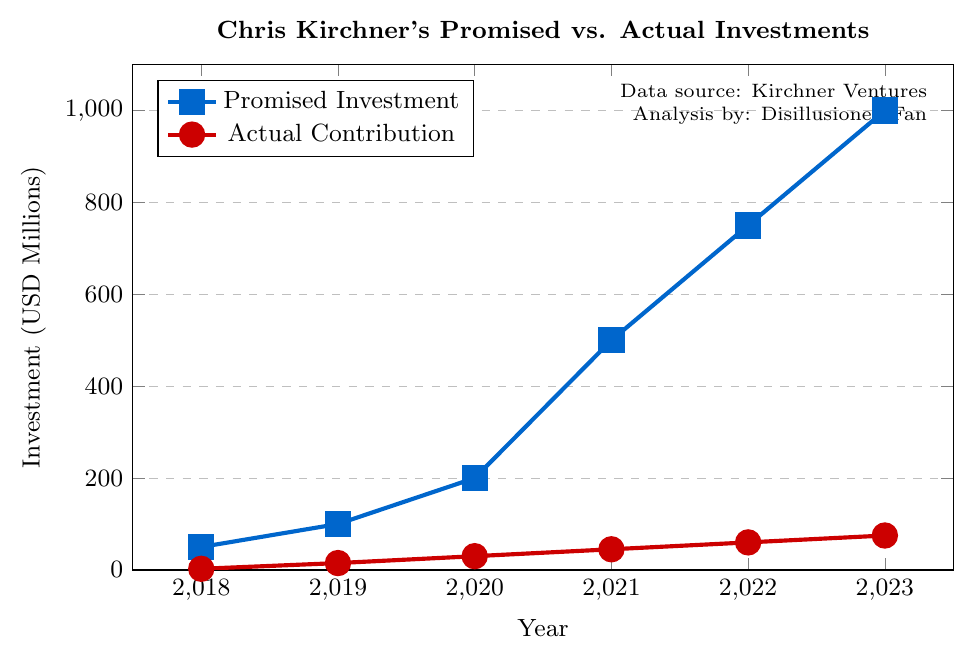How much did Chris Kirchner promise to invest in 2020? Look at the "Promised Investment" line on the chart for the year 2020, it reaches up to 200 million dollars
Answer: 200 million dollars By how much did the actual contribution fall short of the promised investment in 2021? The promised investment for 2021 is 500 million dollars, and the actual contribution is 45 million dollars. Subtract the actual contribution from the promised investment: 500 - 45 = 455 million dollars
Answer: 455 million dollars During which year is the gap between promised investment and actual contribution the largest? Check the differences between promised and actual values for all years. The gaps are: 2018: 47.5, 2019: 85, 2020: 170, 2021: 455, 2022: 690, 2023: 925. The largest gap is in 2023 at 925 million dollars
Answer: 2023 What is the color representation of the actual contributions in the chart? Visualize the colors in the chart; the "Actual Contribution" line is in red
Answer: Red How much total did Chris Kirchner promise to invest over the years 2018-2023? Sum the promised investments: 50 + 100 + 200 + 500 + 750 + 1000 = 2600 million dollars
Answer: 2600 million dollars What is the average annual growth in promised investments from 2018 to 2023? The growth in promised investments can be calculated by taking the difference between the promised investment for 2023 and 2018, then dividing by the number of years: (1000 - 50) / (2023 - 2018) = 950 / 5 = 190 million dollars per year
Answer: 190 million dollars per year How many times more was the promised investment compared to the actual contribution in 2022? Divide the promised investment by the actual contribution for 2022: 750 / 60 ≈ 12.5 times more
Answer: Approximately 12.5 times Is there a year where the actual contribution is at least 10% of the promised investment? Check each year's actual contribution and compare it to 10% of the promised investment:
2018: 2.5 vs. 5 (2.5 is 5%, less)
2019: 15 vs. 10 (15 is 15%, more)
2020: 30 vs. 20 (30 is 15%, more)
2021: 45 vs. 50 (45 is 9%, less)
2022: 60 vs. 75 (60 is 8%, less)
2023: 75 vs. 100 (75 is 7.5%, less)
Years 2019 and 2020 meet the condition
Answer: 2019, 2020 